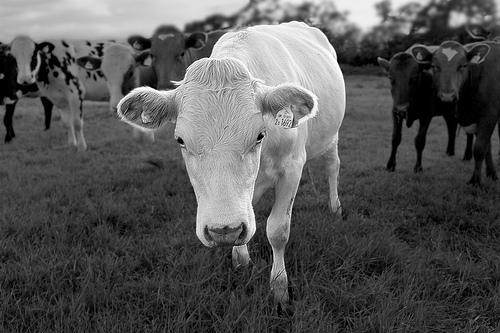Describe the general appearance and position of the vegetation in the image. There is a nice big patch of plush grass in the field, covering a large portion of the image with one section of thick grass present as well. What is the setting of the image, and what is the main object of focus? The setting is a grassy field with cows as the main object of focus, some of which have distinguishable features like tags in their ears. Choose one of the cows in the image and describe its leg features. One of the blonde cows has a knobby knee and joint on one of its front legs, making it an identifiable feature. Identify the type of animal in the image and describe its facial features. There are cows in the image with various facial features, such as dark inquisitive sad eyes, finely furfuzzy ears, and snouts. What is an additional feature found on some of the cows in this image? Give a brief description of this feature. Some cows have identification tags in their ears, with one cow having a tag with the number 2692, although some text above is illegible. Describe the interaction between the cows and their environment in this image. The cows are peacefully grazing in the grassy field, standing on the plush grass, and some trees are visible in the distance. What is a common feature found in the ears of some cows in the image, and provide details about one mentioned instance? A common feature is identification tags on the cows' ears, such as the tag on one cow's left ear, which is hard to read but says 2692 with something illegible on top. What are some of the noticeable characteristics of the sky in the image? The sky in the image is gray with clouds and appears in various parts, such as behind trees and in the upper parts of the image. What types of color combinations are found on the cows in the image? Color combinations include blonde cows, black cows with white patches, and brown cows with white spots and tags in their ears. How would you describe the visual mood or atmosphere of this image? The atmosphere of the image is peaceful and calm, with cows grazing in a grassy field and a gray, cloudy sky above them. 